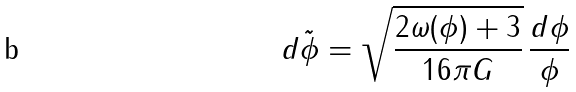Convert formula to latex. <formula><loc_0><loc_0><loc_500><loc_500>d \tilde { \phi } = \sqrt { \frac { 2 \omega ( \phi ) + 3 } { 1 6 \pi G } } \, \frac { d \phi } { \phi }</formula> 